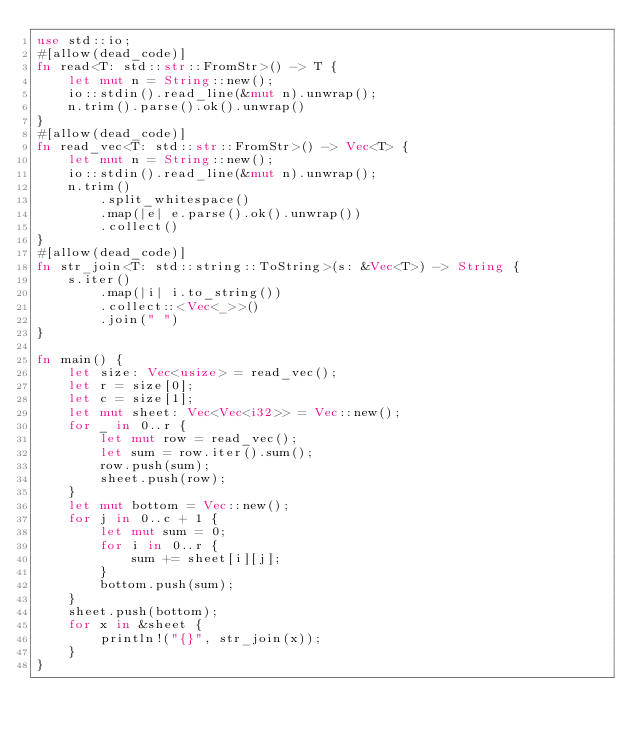<code> <loc_0><loc_0><loc_500><loc_500><_Rust_>use std::io;
#[allow(dead_code)]
fn read<T: std::str::FromStr>() -> T {
    let mut n = String::new();
    io::stdin().read_line(&mut n).unwrap();
    n.trim().parse().ok().unwrap()
}
#[allow(dead_code)]
fn read_vec<T: std::str::FromStr>() -> Vec<T> {
    let mut n = String::new();
    io::stdin().read_line(&mut n).unwrap();
    n.trim()
        .split_whitespace()
        .map(|e| e.parse().ok().unwrap())
        .collect()
}
#[allow(dead_code)]
fn str_join<T: std::string::ToString>(s: &Vec<T>) -> String {
    s.iter()
        .map(|i| i.to_string())
        .collect::<Vec<_>>()
        .join(" ")
}

fn main() {
    let size: Vec<usize> = read_vec();
    let r = size[0];
    let c = size[1];
    let mut sheet: Vec<Vec<i32>> = Vec::new();
    for _ in 0..r {
        let mut row = read_vec();
        let sum = row.iter().sum();
        row.push(sum);
        sheet.push(row);
    }
    let mut bottom = Vec::new();
    for j in 0..c + 1 {
        let mut sum = 0;
        for i in 0..r {
            sum += sheet[i][j];
        }
        bottom.push(sum);
    }
    sheet.push(bottom);
    for x in &sheet {
        println!("{}", str_join(x));
    }
}

</code> 